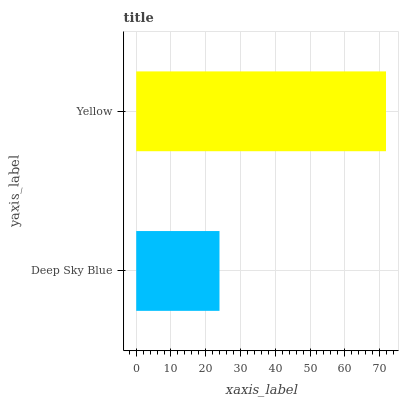Is Deep Sky Blue the minimum?
Answer yes or no. Yes. Is Yellow the maximum?
Answer yes or no. Yes. Is Yellow the minimum?
Answer yes or no. No. Is Yellow greater than Deep Sky Blue?
Answer yes or no. Yes. Is Deep Sky Blue less than Yellow?
Answer yes or no. Yes. Is Deep Sky Blue greater than Yellow?
Answer yes or no. No. Is Yellow less than Deep Sky Blue?
Answer yes or no. No. Is Yellow the high median?
Answer yes or no. Yes. Is Deep Sky Blue the low median?
Answer yes or no. Yes. Is Deep Sky Blue the high median?
Answer yes or no. No. Is Yellow the low median?
Answer yes or no. No. 